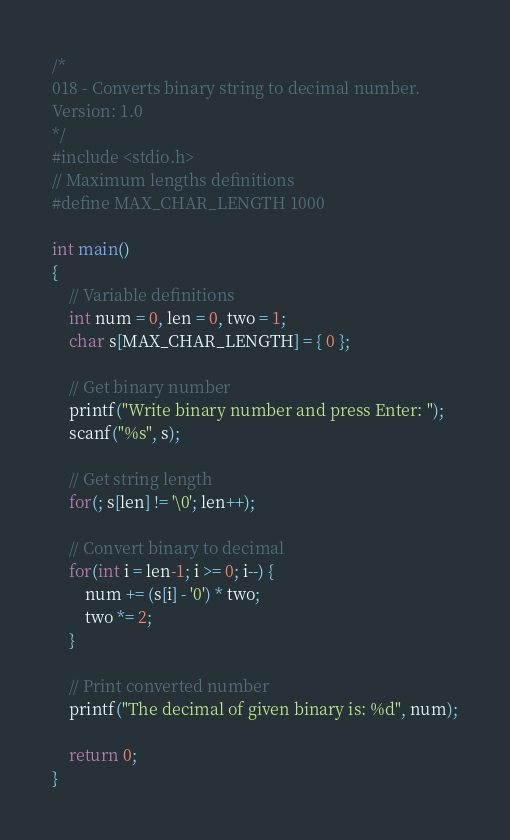Convert code to text. <code><loc_0><loc_0><loc_500><loc_500><_C_>/*
018 - Converts binary string to decimal number.
Version: 1.0
*/
#include <stdio.h>
// Maximum lengths definitions
#define MAX_CHAR_LENGTH 1000

int main()
{
    // Variable definitions
    int num = 0, len = 0, two = 1;
    char s[MAX_CHAR_LENGTH] = { 0 };

    // Get binary number
    printf("Write binary number and press Enter: ");
    scanf("%s", s);

    // Get string length
    for(; s[len] != '\0'; len++);

    // Convert binary to decimal
    for(int i = len-1; i >= 0; i--) {
        num += (s[i] - '0') * two;
        two *= 2;
    }

    // Print converted number
    printf("The decimal of given binary is: %d", num);

    return 0;
}</code> 